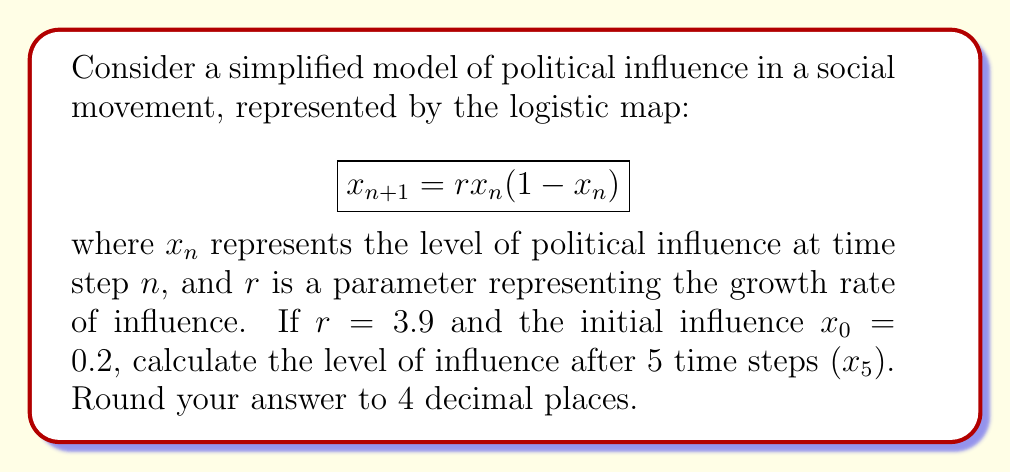What is the answer to this math problem? To solve this problem, we need to iterate the logistic map equation for 5 time steps:

1) For $n = 0$:
   $x_1 = 3.9 \cdot 0.2 \cdot (1-0.2) = 0.624$

2) For $n = 1$:
   $x_2 = 3.9 \cdot 0.624 \cdot (1-0.624) = 0.9165216$

3) For $n = 2$:
   $x_3 = 3.9 \cdot 0.9165216 \cdot (1-0.9165216) = 0.3000824$

4) For $n = 3$:
   $x_4 = 3.9 \cdot 0.3000824 \cdot (1-0.3000824) = 0.8188392$

5) For $n = 4$:
   $x_5 = 3.9 \cdot 0.8188392 \cdot (1-0.8188392) = 0.5789605$

Rounding to 4 decimal places, we get 0.5790.

This demonstrates the chaotic behavior in social movements, where small changes in initial conditions can lead to significantly different outcomes over time, making long-term predictions challenging.
Answer: 0.5790 